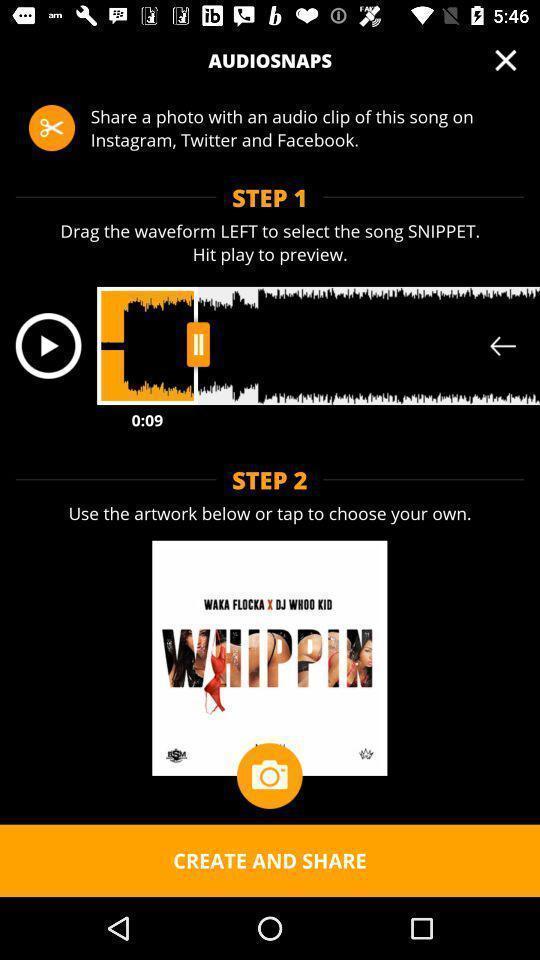Please provide a description for this image. Page showing instructions in an entertainment app. 